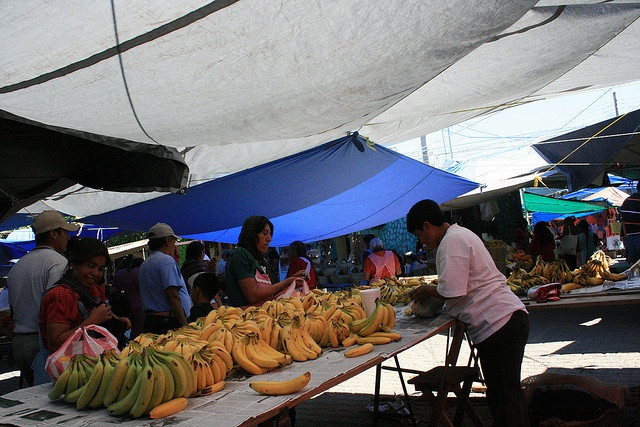Describe the objects in this image and their specific colors. I can see banana in darkgray, black, brown, maroon, and olive tones, people in darkgray, black, and gray tones, people in darkgray, black, and gray tones, people in darkgray, black, maroon, blue, and gray tones, and people in darkgray, black, navy, and gray tones in this image. 